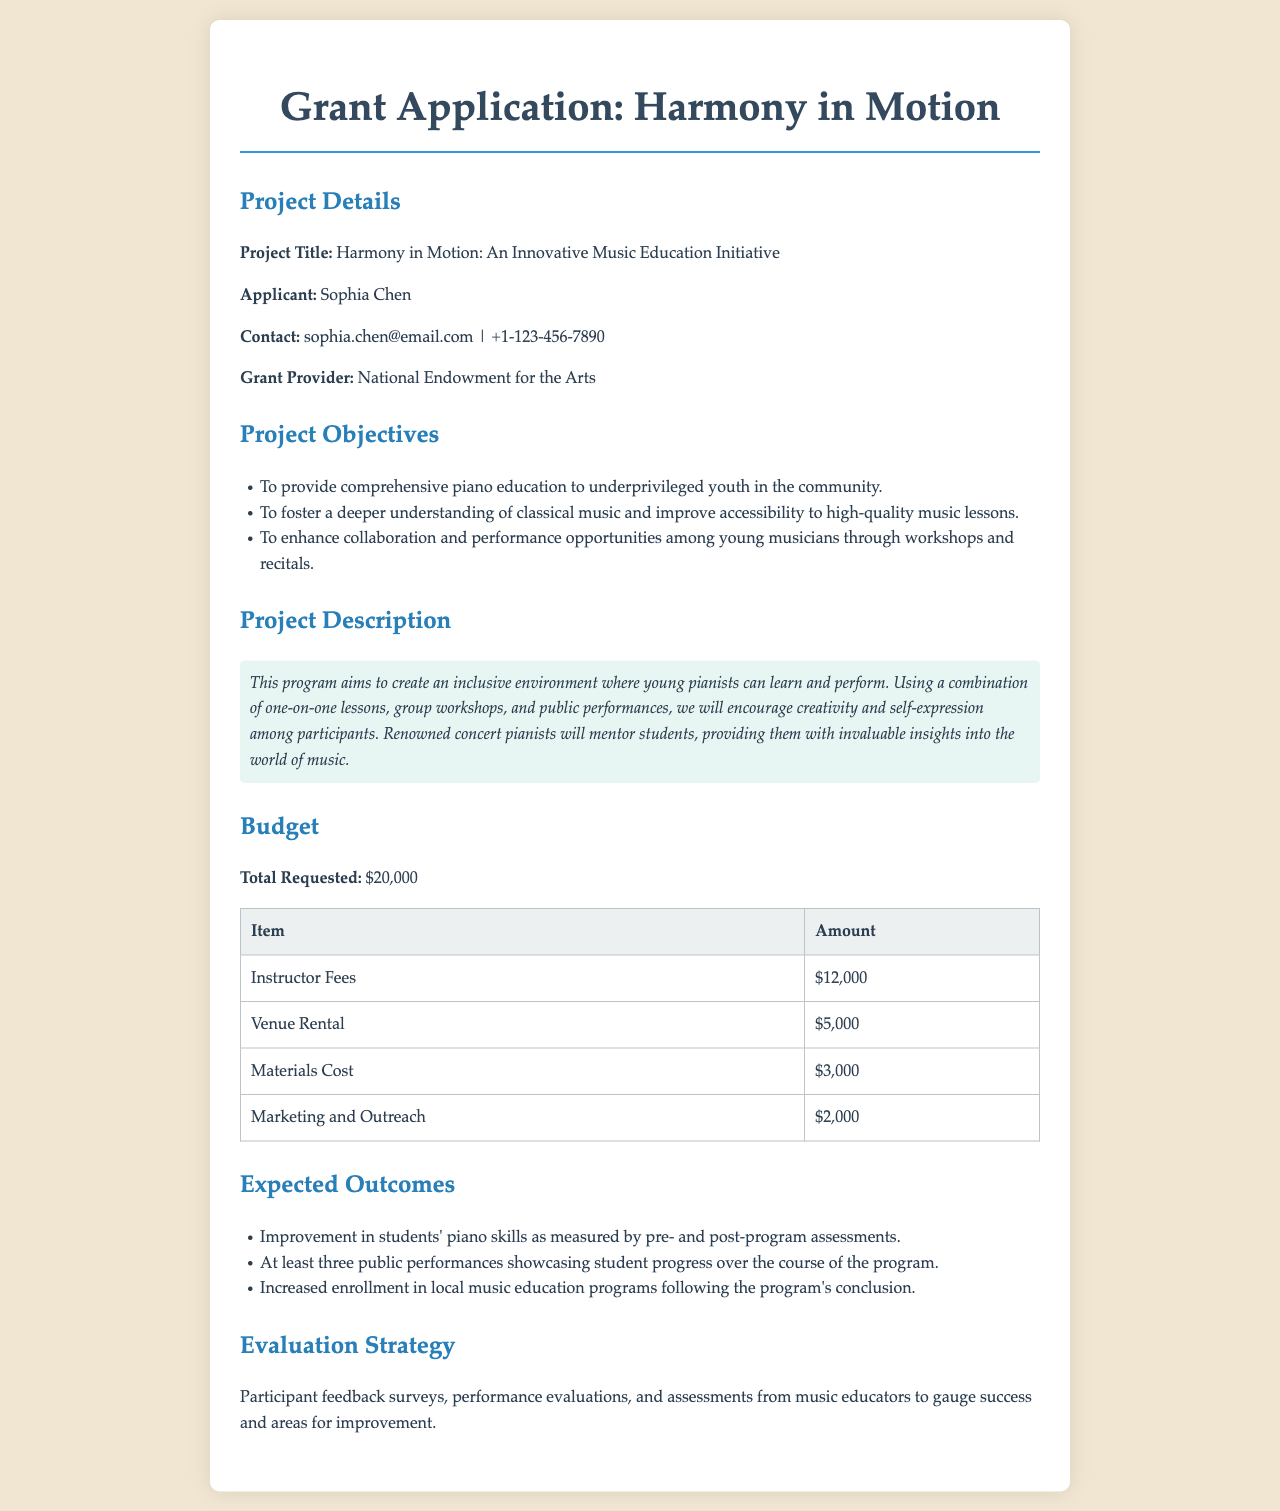What is the project title? The project title is clearly stated in the document as part of the project details.
Answer: Harmony in Motion: An Innovative Music Education Initiative Who is the applicant? The applicant's name is mentioned in the project details section of the document.
Answer: Sophia Chen What is the total requested amount? The total requested amount is listed under the budget section of the document.
Answer: $20,000 How much is allocated for instructor fees? The instructor fees are one of the budget items that provide a specific amount in the document.
Answer: $12,000 What type of educational approach is used in the program? The program description indicates the methods used for teaching are relevant to the music education initiative outlined.
Answer: One-on-one lessons, group workshops, and public performances What is one expected outcome of the program? The expected outcomes list several achievements that will result from the program, highlighting benefits for participants.
Answer: Improvement in students' piano skills How will the program's success be evaluated? The evaluation strategy section mentions specific methods for assessing achievements and areas for improvement.
Answer: Participant feedback surveys What is the primary purpose of the Harmony in Motion project? The objectives section outlines the goals and intended impact of the project on the community.
Answer: To provide comprehensive piano education to underprivileged youth in the community 